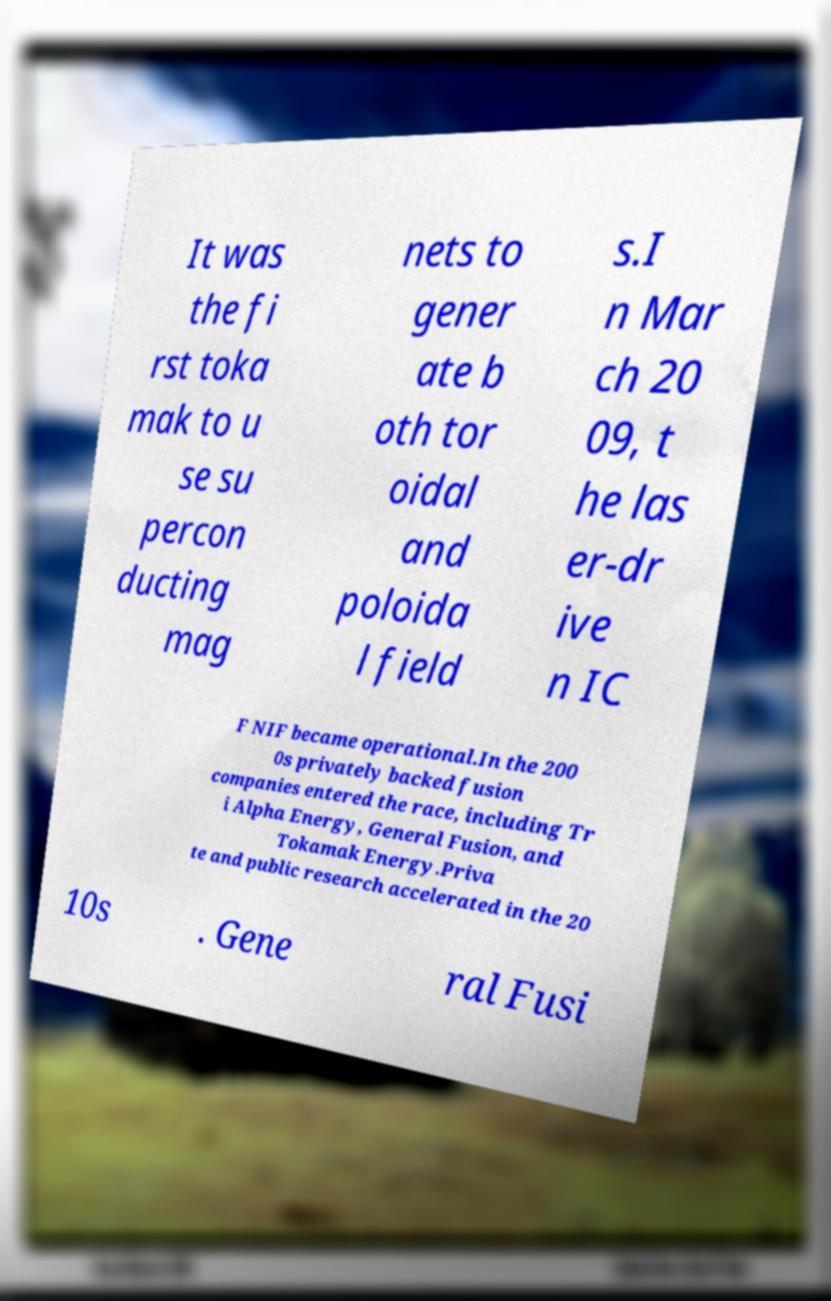For documentation purposes, I need the text within this image transcribed. Could you provide that? It was the fi rst toka mak to u se su percon ducting mag nets to gener ate b oth tor oidal and poloida l field s.I n Mar ch 20 09, t he las er-dr ive n IC F NIF became operational.In the 200 0s privately backed fusion companies entered the race, including Tr i Alpha Energy, General Fusion, and Tokamak Energy.Priva te and public research accelerated in the 20 10s . Gene ral Fusi 